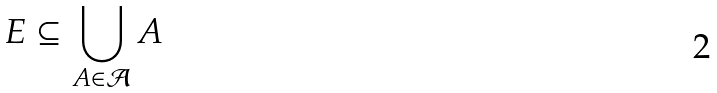Convert formula to latex. <formula><loc_0><loc_0><loc_500><loc_500>E \subseteq \bigcup _ { A \in \mathcal { A } } A</formula> 